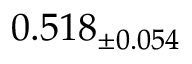<formula> <loc_0><loc_0><loc_500><loc_500>0 . 5 1 8 _ { \pm 0 . 0 5 4 }</formula> 